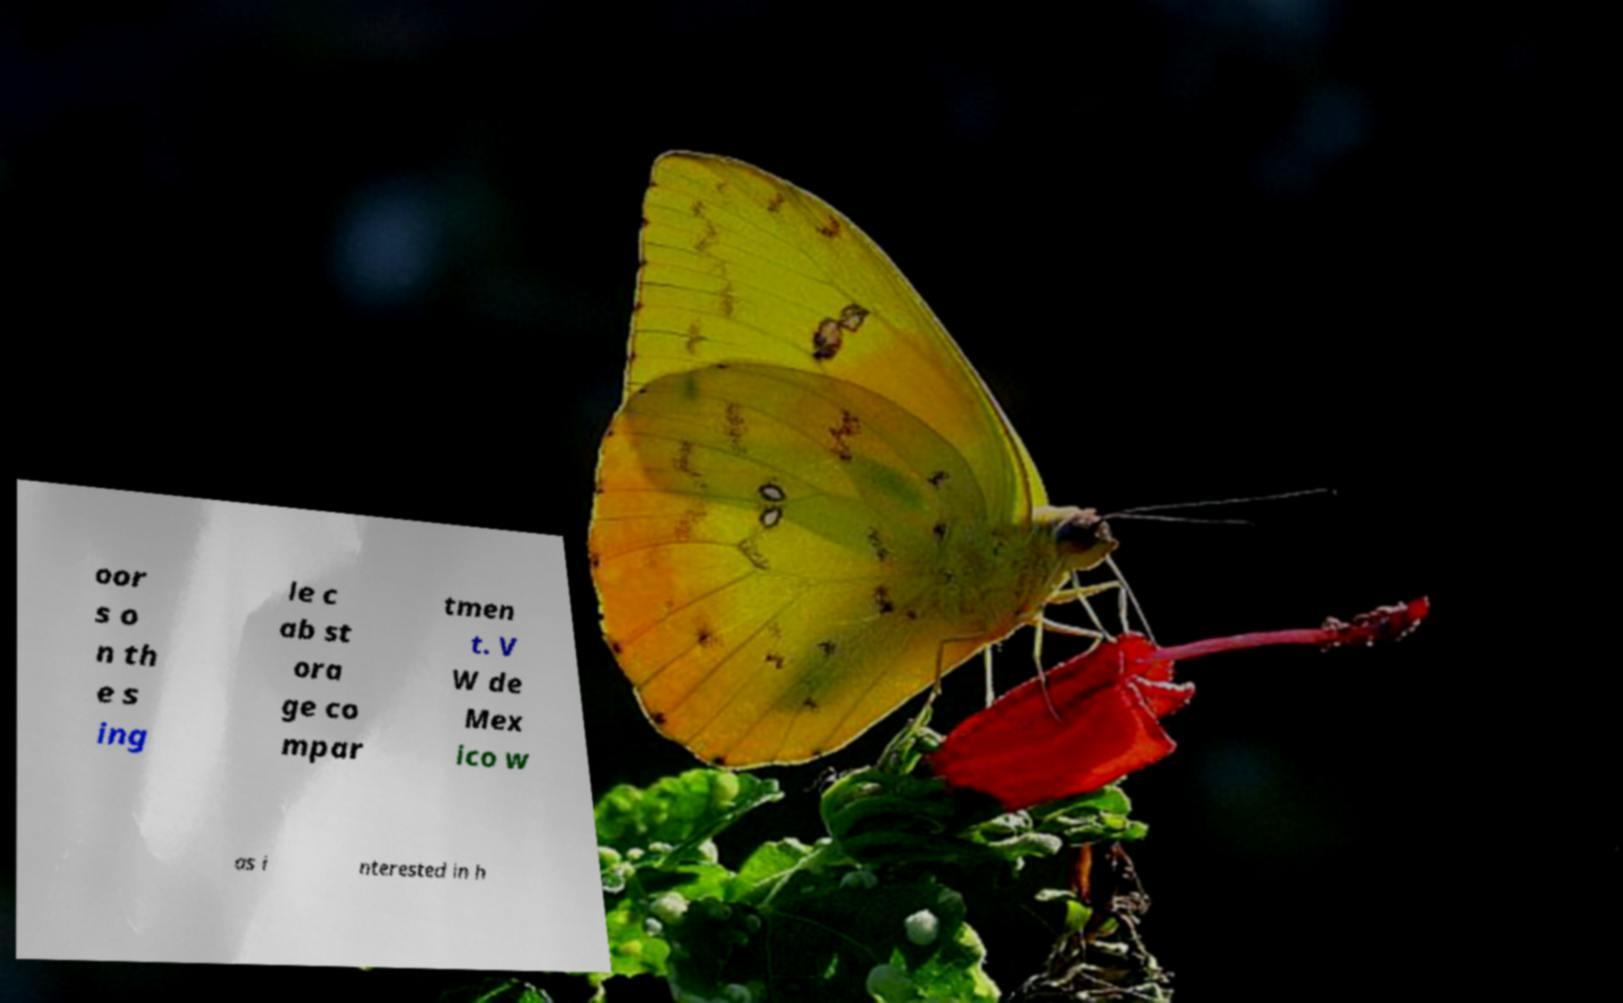I need the written content from this picture converted into text. Can you do that? oor s o n th e s ing le c ab st ora ge co mpar tmen t. V W de Mex ico w as i nterested in h 